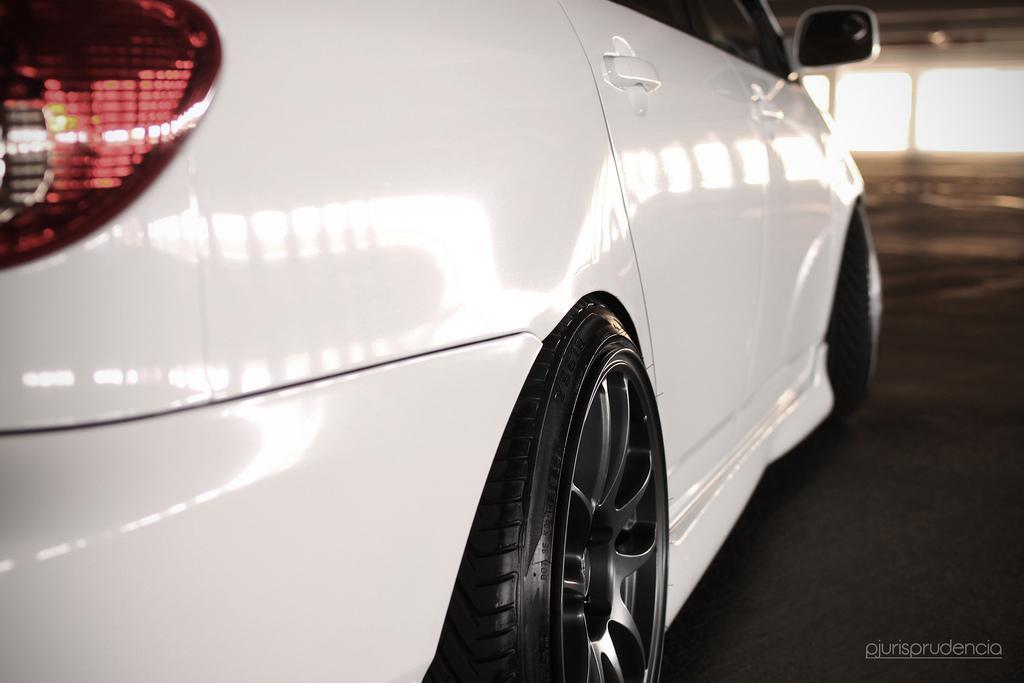In one or two sentences, can you explain what this image depicts? This is the truncated image of a car. In the background, we can see the floor and the glass windows. 